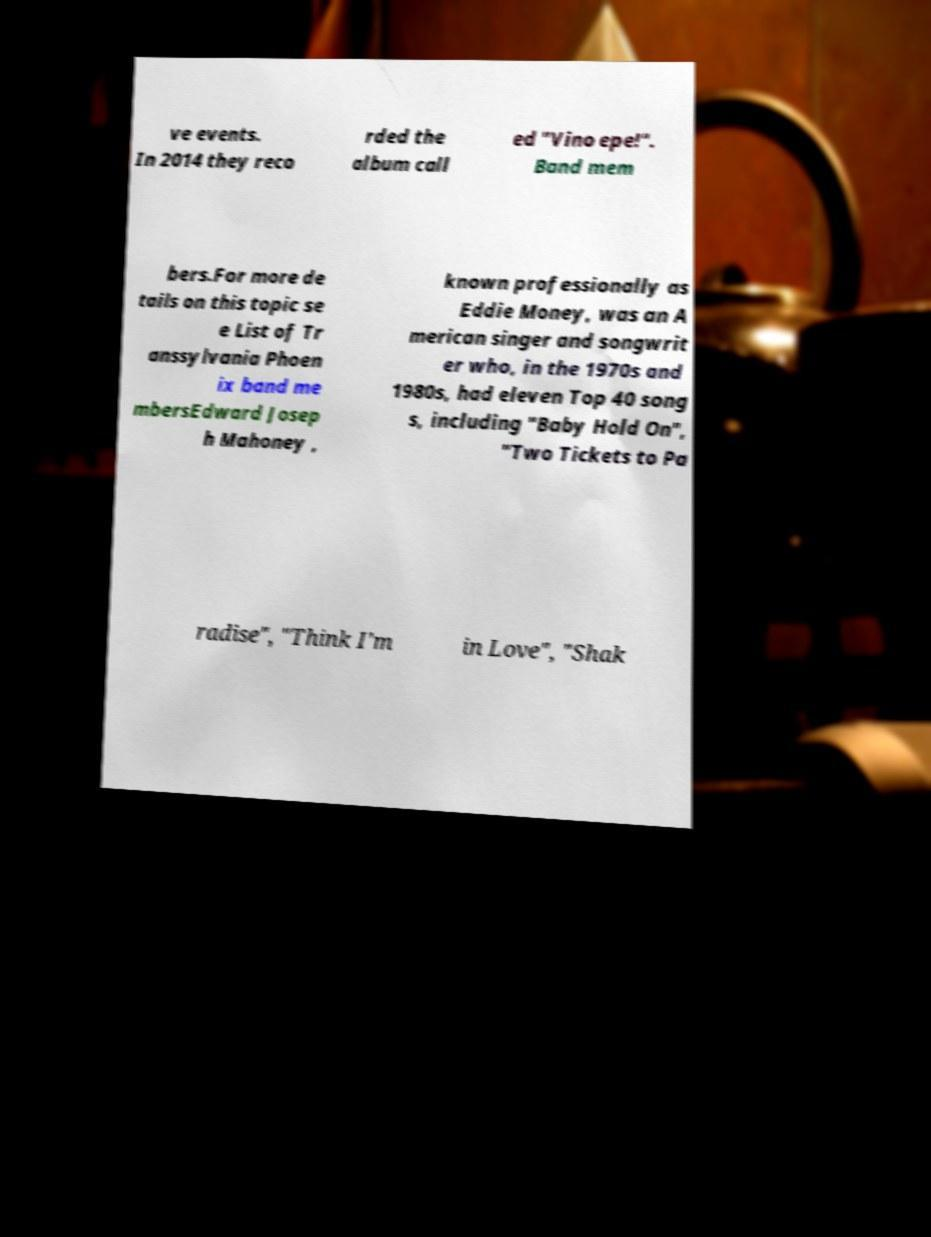Please read and relay the text visible in this image. What does it say? ve events. In 2014 they reco rded the album call ed "Vino epe!". Band mem bers.For more de tails on this topic se e List of Tr anssylvania Phoen ix band me mbersEdward Josep h Mahoney , known professionally as Eddie Money, was an A merican singer and songwrit er who, in the 1970s and 1980s, had eleven Top 40 song s, including "Baby Hold On", "Two Tickets to Pa radise", "Think I'm in Love", "Shak 